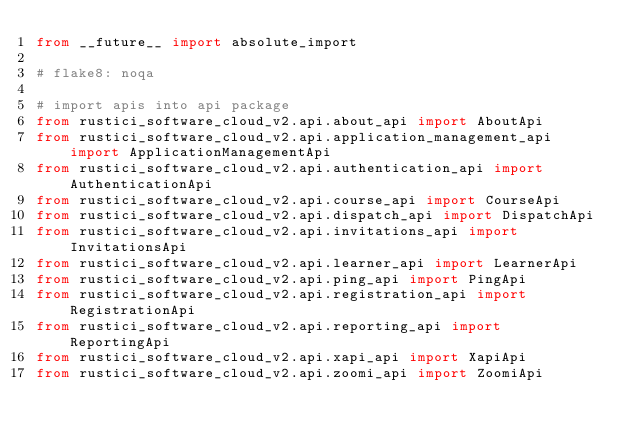Convert code to text. <code><loc_0><loc_0><loc_500><loc_500><_Python_>from __future__ import absolute_import

# flake8: noqa

# import apis into api package
from rustici_software_cloud_v2.api.about_api import AboutApi
from rustici_software_cloud_v2.api.application_management_api import ApplicationManagementApi
from rustici_software_cloud_v2.api.authentication_api import AuthenticationApi
from rustici_software_cloud_v2.api.course_api import CourseApi
from rustici_software_cloud_v2.api.dispatch_api import DispatchApi
from rustici_software_cloud_v2.api.invitations_api import InvitationsApi
from rustici_software_cloud_v2.api.learner_api import LearnerApi
from rustici_software_cloud_v2.api.ping_api import PingApi
from rustici_software_cloud_v2.api.registration_api import RegistrationApi
from rustici_software_cloud_v2.api.reporting_api import ReportingApi
from rustici_software_cloud_v2.api.xapi_api import XapiApi
from rustici_software_cloud_v2.api.zoomi_api import ZoomiApi
</code> 